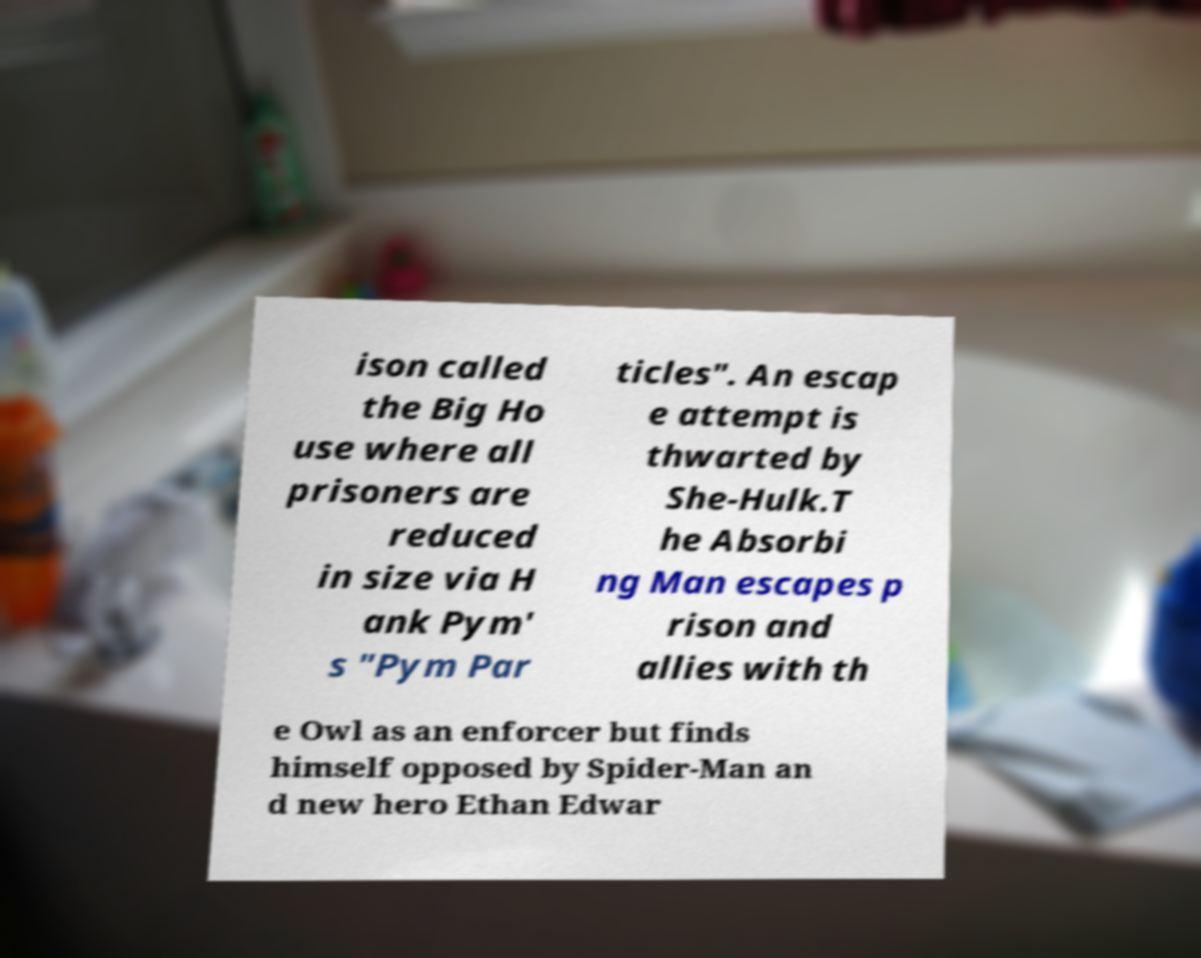Could you extract and type out the text from this image? ison called the Big Ho use where all prisoners are reduced in size via H ank Pym' s "Pym Par ticles". An escap e attempt is thwarted by She-Hulk.T he Absorbi ng Man escapes p rison and allies with th e Owl as an enforcer but finds himself opposed by Spider-Man an d new hero Ethan Edwar 